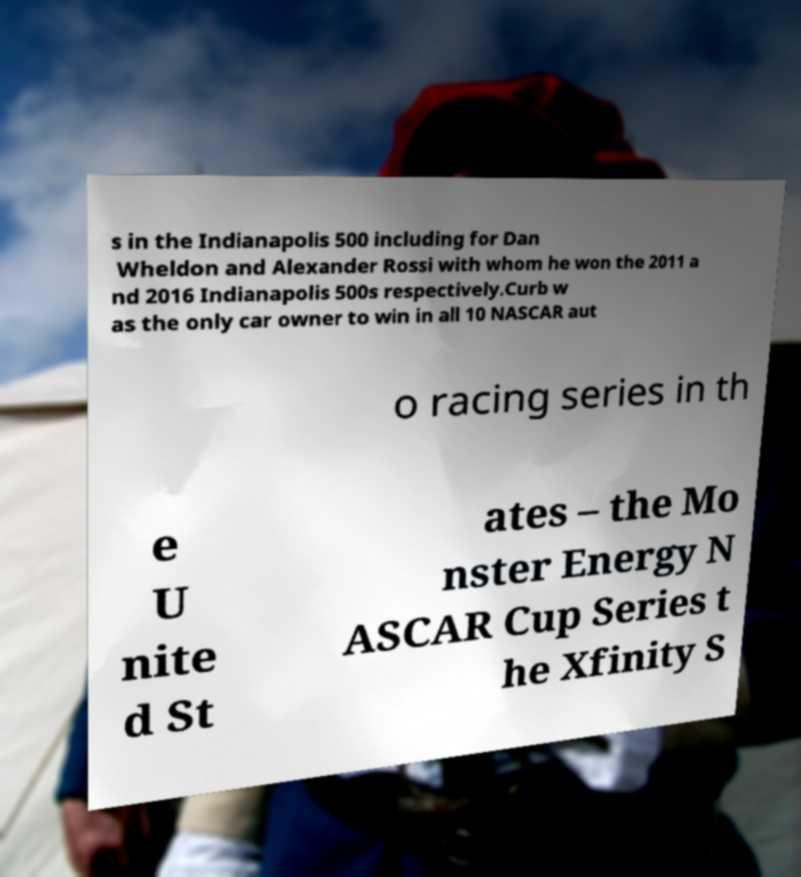For documentation purposes, I need the text within this image transcribed. Could you provide that? s in the Indianapolis 500 including for Dan Wheldon and Alexander Rossi with whom he won the 2011 a nd 2016 Indianapolis 500s respectively.Curb w as the only car owner to win in all 10 NASCAR aut o racing series in th e U nite d St ates – the Mo nster Energy N ASCAR Cup Series t he Xfinity S 